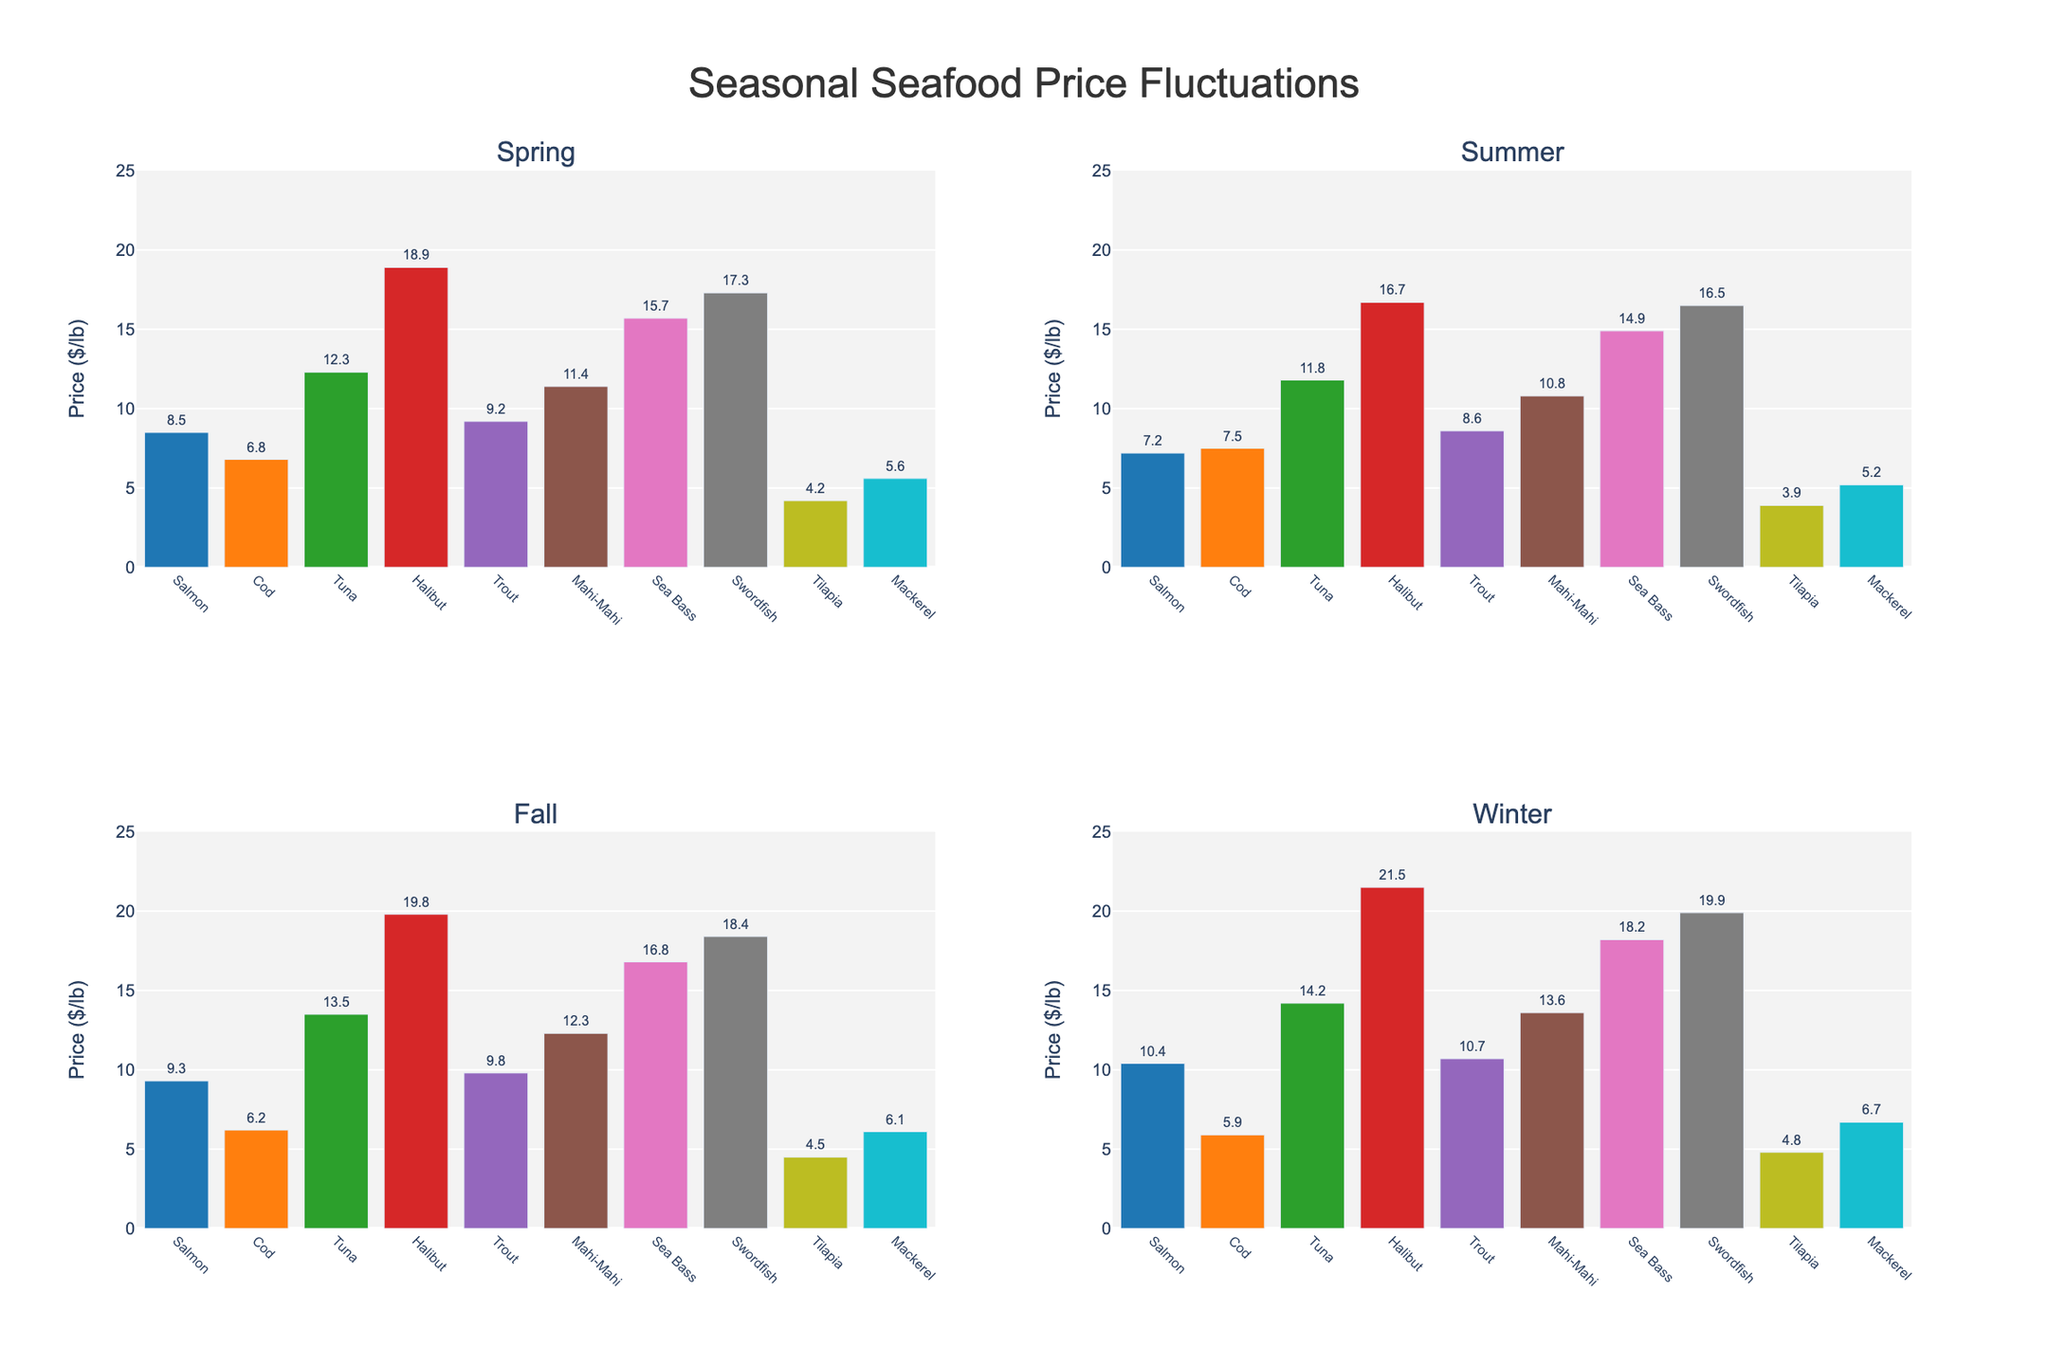Which fish variety has the highest price in Winter? To find the fish variety with the highest price in Winter, we look for the tallest bar in the "Winter" subplot. The tallest bar represents Halibut with a price of $21.50 per pound.
Answer: Halibut Which season offers the lowest price for Tilapia? To determine the season with the lowest price for Tilapia, compare the heights of the Tilapia bars across all four seasons. The shortest bar representing Tilapia is in Summer, priced at $3.90 per pound.
Answer: Summer What is the price difference between Salmon and Mackerel in Spring? To calculate the price difference, we need the prices for Salmon and Mackerel in Spring. Salmon is $8.50 per pound and Mackerel is $5.60 per pound. The difference is $8.50 - $5.60 = $2.90.
Answer: $2.90 Which fish variety shows the most consistent prices across all seasons? Consistency in prices can be identified by finding the fish variety with bars of nearly equal height across all four subplots. Cod has relatively consistent prices across the seasons: $6.80, $7.50, $6.20, and $5.90 per pound.
Answer: Cod Which season has the highest average price for all fish varieties? To find the highest average price across all fish varieties in a specific season, sum up the prices of all varieties for each season and find their averages:
Spring: (8.50+6.80+12.30+18.90+9.20+11.40+15.70+17.30+4.20+5.60)/10 = 11.49
Summer: (7.20+7.50+11.80+16.70+8.60+10.80+14.90+16.50+3.90+5.20)/10 = 10.81
Fall: (9.30+6.20+13.50+19.80+9.80+12.30+16.80+18.40+4.50+6.10)/10 = 11.97
Winter: (10.40+5.90+14.20+21.50+10.70+13.60+18.20+19.90+4.80+6.70)/10 = 12.79
Winter has the highest average price at $12.79 per pound.
Answer: Winter 